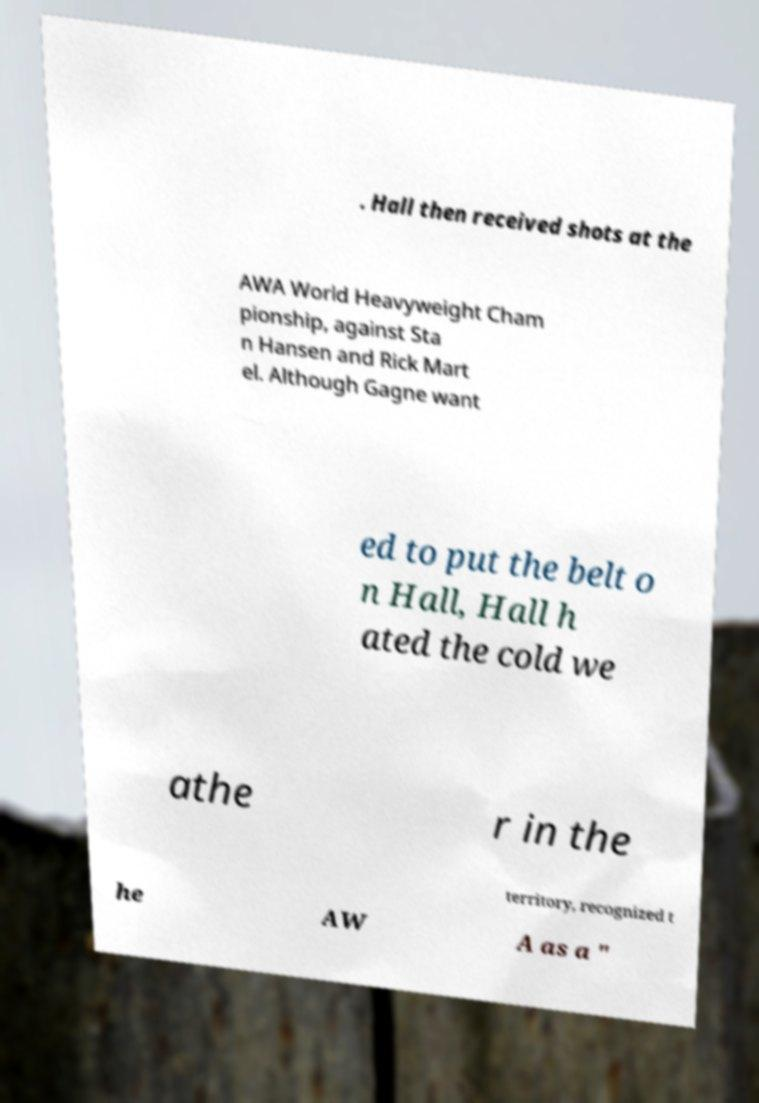Please read and relay the text visible in this image. What does it say? . Hall then received shots at the AWA World Heavyweight Cham pionship, against Sta n Hansen and Rick Mart el. Although Gagne want ed to put the belt o n Hall, Hall h ated the cold we athe r in the territory, recognized t he AW A as a " 